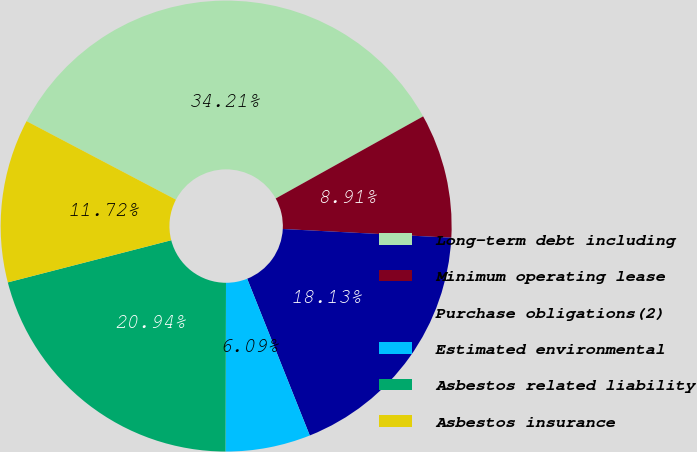Convert chart. <chart><loc_0><loc_0><loc_500><loc_500><pie_chart><fcel>Long-term debt including<fcel>Minimum operating lease<fcel>Purchase obligations(2)<fcel>Estimated environmental<fcel>Asbestos related liability<fcel>Asbestos insurance<nl><fcel>34.21%<fcel>8.91%<fcel>18.13%<fcel>6.09%<fcel>20.94%<fcel>11.72%<nl></chart> 